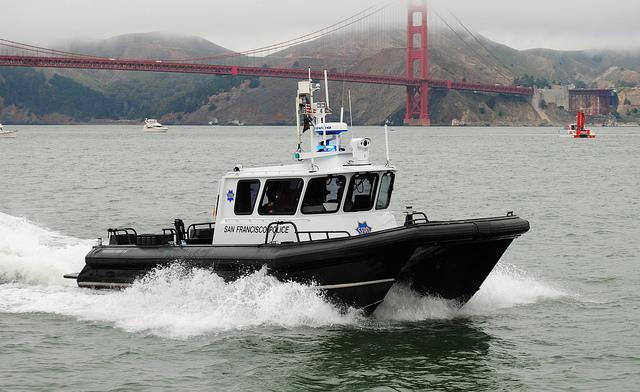What color is the body of this police boat?
Indicate the correct choice and explain in the format: 'Answer: answer
Rationale: rationale.'
Options: Blue, green, black, white. Answer: black.
Rationale: The boat has a dark color for the inflatable part of the boat. 